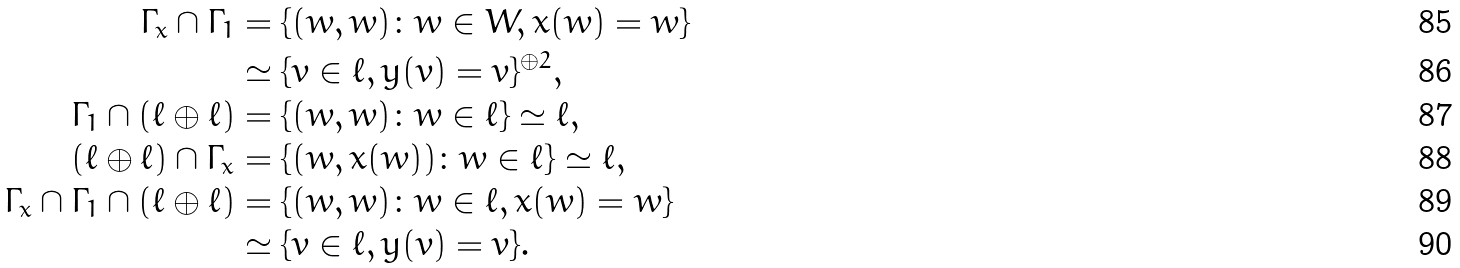Convert formula to latex. <formula><loc_0><loc_0><loc_500><loc_500>\Gamma _ { x } \cap \Gamma _ { 1 } & = \{ ( w , w ) \colon w \in W , x ( w ) = w \} \\ & \simeq \{ v \in \ell , y ( v ) = v \} ^ { \oplus 2 } , \\ \Gamma _ { 1 } \cap ( \ell \oplus \ell ) & = \{ ( w , w ) \colon w \in \ell \} \simeq \ell , \\ ( \ell \oplus \ell ) \cap \Gamma _ { x } & = \{ ( w , x ( w ) ) \colon w \in \ell \} \simeq \ell , \\ \Gamma _ { x } \cap \Gamma _ { 1 } \cap ( \ell \oplus \ell ) & = \{ ( w , w ) \colon w \in \ell , x ( w ) = w \} \\ & \simeq \{ v \in \ell , y ( v ) = v \} .</formula> 